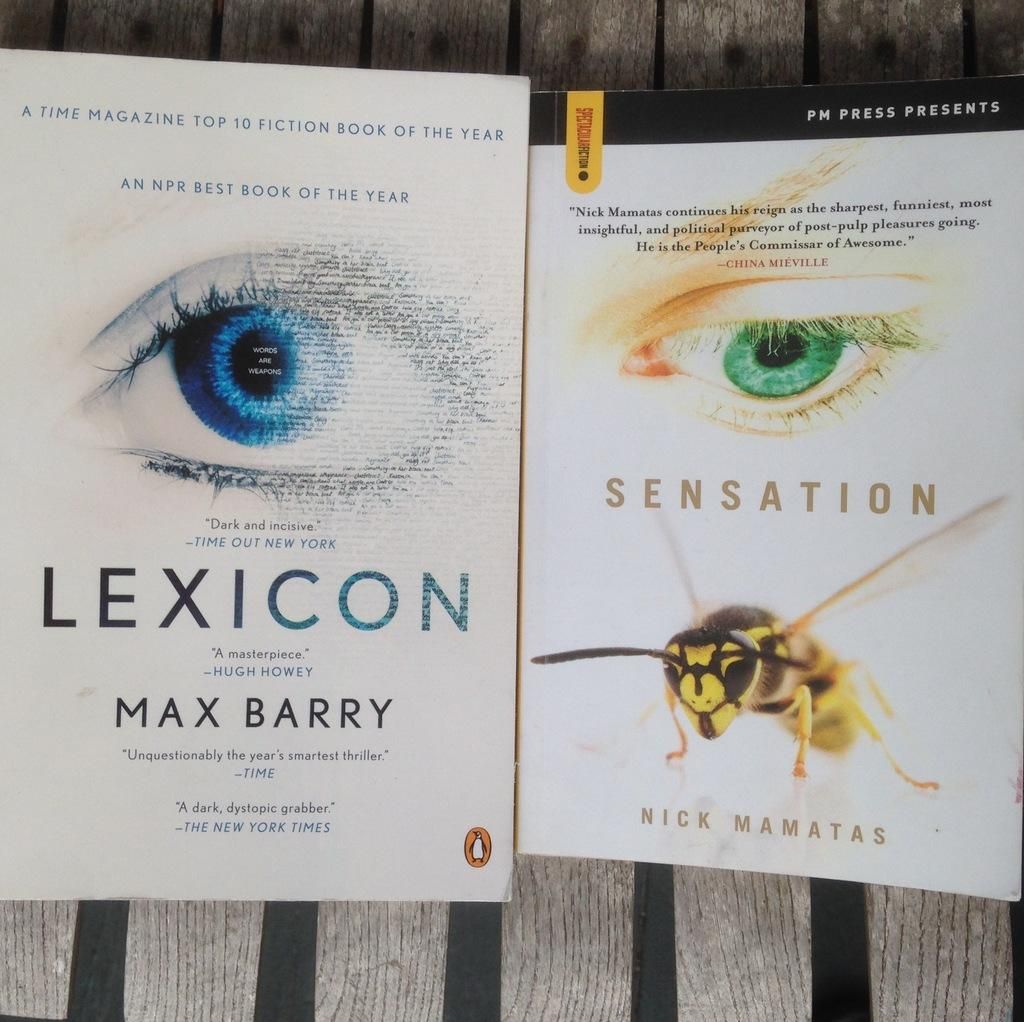How many books are visible in the image? There are two books in the image. What can be seen on the books? There is writing on the books, as well as depictions of human eyes and an insect. What type of corn is being suggested in the image? There is no corn present in the image, so it cannot be suggested. 